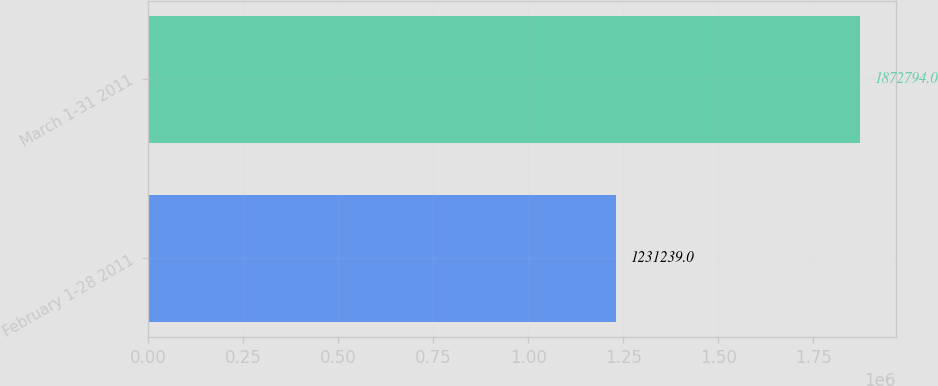Convert chart. <chart><loc_0><loc_0><loc_500><loc_500><bar_chart><fcel>February 1-28 2011<fcel>March 1-31 2011<nl><fcel>1.23124e+06<fcel>1.87279e+06<nl></chart> 